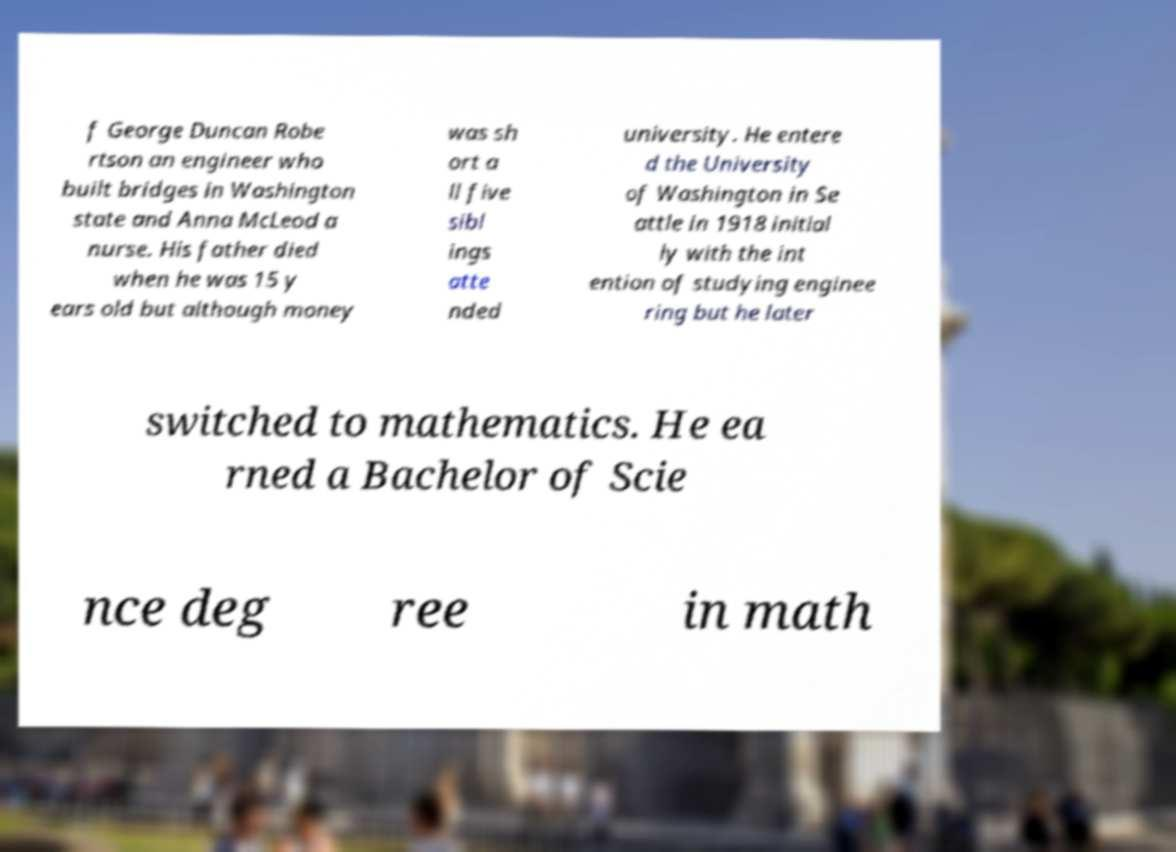Please identify and transcribe the text found in this image. f George Duncan Robe rtson an engineer who built bridges in Washington state and Anna McLeod a nurse. His father died when he was 15 y ears old but although money was sh ort a ll five sibl ings atte nded university. He entere d the University of Washington in Se attle in 1918 initial ly with the int ention of studying enginee ring but he later switched to mathematics. He ea rned a Bachelor of Scie nce deg ree in math 